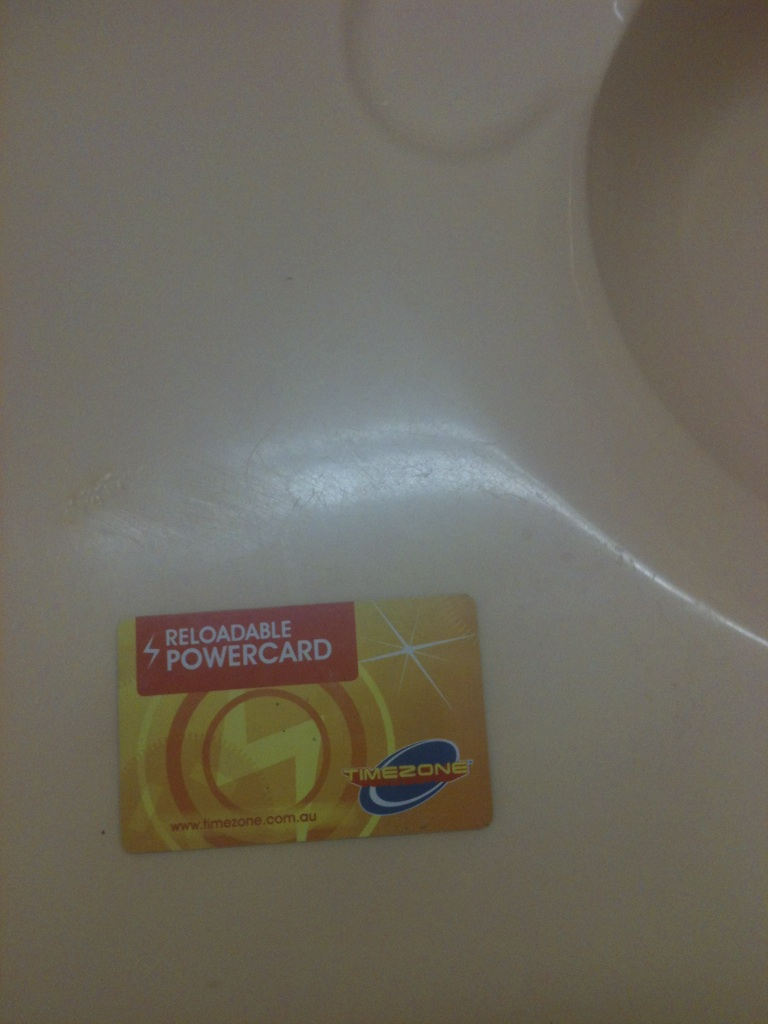What card is this? The card shown in the image is a Reloadable Powercard from Timezone, which is used for playing games at Timezone entertainment centers. It can be reloaded with credits that allow you to play various arcade games. 